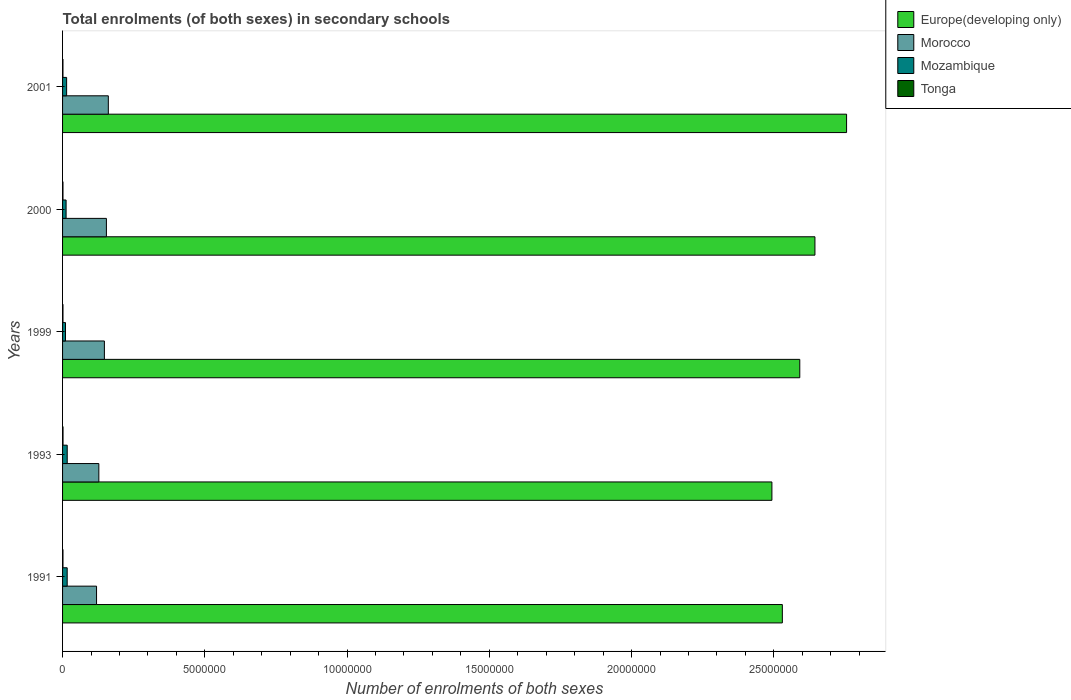How many different coloured bars are there?
Your answer should be compact. 4. How many groups of bars are there?
Make the answer very short. 5. How many bars are there on the 1st tick from the top?
Keep it short and to the point. 4. In how many cases, is the number of bars for a given year not equal to the number of legend labels?
Give a very brief answer. 0. What is the number of enrolments in secondary schools in Mozambique in 1999?
Your answer should be very brief. 1.03e+05. Across all years, what is the maximum number of enrolments in secondary schools in Mozambique?
Your response must be concise. 1.64e+05. Across all years, what is the minimum number of enrolments in secondary schools in Tonga?
Ensure brevity in your answer.  1.41e+04. In which year was the number of enrolments in secondary schools in Europe(developing only) maximum?
Give a very brief answer. 2001. In which year was the number of enrolments in secondary schools in Tonga minimum?
Your response must be concise. 2001. What is the total number of enrolments in secondary schools in Europe(developing only) in the graph?
Ensure brevity in your answer.  1.30e+08. What is the difference between the number of enrolments in secondary schools in Europe(developing only) in 1991 and that in 1993?
Your response must be concise. 3.67e+05. What is the difference between the number of enrolments in secondary schools in Europe(developing only) in 2000 and the number of enrolments in secondary schools in Morocco in 1999?
Ensure brevity in your answer.  2.50e+07. What is the average number of enrolments in secondary schools in Tonga per year?
Give a very brief answer. 1.50e+04. In the year 2001, what is the difference between the number of enrolments in secondary schools in Europe(developing only) and number of enrolments in secondary schools in Morocco?
Ensure brevity in your answer.  2.59e+07. What is the ratio of the number of enrolments in secondary schools in Tonga in 2000 to that in 2001?
Give a very brief answer. 1.03. What is the difference between the highest and the second highest number of enrolments in secondary schools in Morocco?
Offer a terse response. 6.72e+04. What is the difference between the highest and the lowest number of enrolments in secondary schools in Europe(developing only)?
Give a very brief answer. 2.62e+06. What does the 1st bar from the top in 1993 represents?
Offer a terse response. Tonga. What does the 1st bar from the bottom in 2001 represents?
Your response must be concise. Europe(developing only). Is it the case that in every year, the sum of the number of enrolments in secondary schools in Europe(developing only) and number of enrolments in secondary schools in Mozambique is greater than the number of enrolments in secondary schools in Tonga?
Provide a short and direct response. Yes. How many bars are there?
Your answer should be compact. 20. How many years are there in the graph?
Your answer should be very brief. 5. What is the difference between two consecutive major ticks on the X-axis?
Give a very brief answer. 5.00e+06. Does the graph contain grids?
Your answer should be compact. No. Where does the legend appear in the graph?
Give a very brief answer. Top right. How many legend labels are there?
Your response must be concise. 4. What is the title of the graph?
Give a very brief answer. Total enrolments (of both sexes) in secondary schools. Does "Samoa" appear as one of the legend labels in the graph?
Your response must be concise. No. What is the label or title of the X-axis?
Give a very brief answer. Number of enrolments of both sexes. What is the Number of enrolments of both sexes in Europe(developing only) in 1991?
Your answer should be compact. 2.53e+07. What is the Number of enrolments of both sexes of Morocco in 1991?
Offer a very short reply. 1.19e+06. What is the Number of enrolments of both sexes in Mozambique in 1991?
Keep it short and to the point. 1.62e+05. What is the Number of enrolments of both sexes of Tonga in 1991?
Provide a succinct answer. 1.48e+04. What is the Number of enrolments of both sexes of Europe(developing only) in 1993?
Keep it short and to the point. 2.49e+07. What is the Number of enrolments of both sexes of Morocco in 1993?
Provide a succinct answer. 1.27e+06. What is the Number of enrolments of both sexes of Mozambique in 1993?
Keep it short and to the point. 1.64e+05. What is the Number of enrolments of both sexes in Tonga in 1993?
Keep it short and to the point. 1.66e+04. What is the Number of enrolments of both sexes of Europe(developing only) in 1999?
Give a very brief answer. 2.59e+07. What is the Number of enrolments of both sexes in Morocco in 1999?
Keep it short and to the point. 1.47e+06. What is the Number of enrolments of both sexes in Mozambique in 1999?
Make the answer very short. 1.03e+05. What is the Number of enrolments of both sexes of Tonga in 1999?
Ensure brevity in your answer.  1.47e+04. What is the Number of enrolments of both sexes of Europe(developing only) in 2000?
Make the answer very short. 2.64e+07. What is the Number of enrolments of both sexes of Morocco in 2000?
Offer a terse response. 1.54e+06. What is the Number of enrolments of both sexes of Mozambique in 2000?
Provide a succinct answer. 1.24e+05. What is the Number of enrolments of both sexes in Tonga in 2000?
Give a very brief answer. 1.45e+04. What is the Number of enrolments of both sexes of Europe(developing only) in 2001?
Your response must be concise. 2.76e+07. What is the Number of enrolments of both sexes in Morocco in 2001?
Offer a terse response. 1.61e+06. What is the Number of enrolments of both sexes of Mozambique in 2001?
Ensure brevity in your answer.  1.43e+05. What is the Number of enrolments of both sexes in Tonga in 2001?
Your answer should be very brief. 1.41e+04. Across all years, what is the maximum Number of enrolments of both sexes in Europe(developing only)?
Make the answer very short. 2.76e+07. Across all years, what is the maximum Number of enrolments of both sexes of Morocco?
Your answer should be very brief. 1.61e+06. Across all years, what is the maximum Number of enrolments of both sexes in Mozambique?
Give a very brief answer. 1.64e+05. Across all years, what is the maximum Number of enrolments of both sexes of Tonga?
Your response must be concise. 1.66e+04. Across all years, what is the minimum Number of enrolments of both sexes in Europe(developing only)?
Your response must be concise. 2.49e+07. Across all years, what is the minimum Number of enrolments of both sexes in Morocco?
Provide a short and direct response. 1.19e+06. Across all years, what is the minimum Number of enrolments of both sexes in Mozambique?
Ensure brevity in your answer.  1.03e+05. Across all years, what is the minimum Number of enrolments of both sexes in Tonga?
Keep it short and to the point. 1.41e+04. What is the total Number of enrolments of both sexes of Europe(developing only) in the graph?
Offer a terse response. 1.30e+08. What is the total Number of enrolments of both sexes of Morocco in the graph?
Make the answer very short. 7.09e+06. What is the total Number of enrolments of both sexes of Mozambique in the graph?
Your answer should be very brief. 6.96e+05. What is the total Number of enrolments of both sexes in Tonga in the graph?
Ensure brevity in your answer.  7.48e+04. What is the difference between the Number of enrolments of both sexes of Europe(developing only) in 1991 and that in 1993?
Offer a terse response. 3.67e+05. What is the difference between the Number of enrolments of both sexes in Morocco in 1991 and that in 1993?
Provide a short and direct response. -8.06e+04. What is the difference between the Number of enrolments of both sexes in Mozambique in 1991 and that in 1993?
Your answer should be very brief. -1261. What is the difference between the Number of enrolments of both sexes of Tonga in 1991 and that in 1993?
Keep it short and to the point. -1745. What is the difference between the Number of enrolments of both sexes in Europe(developing only) in 1991 and that in 1999?
Ensure brevity in your answer.  -6.13e+05. What is the difference between the Number of enrolments of both sexes of Morocco in 1991 and that in 1999?
Make the answer very short. -2.75e+05. What is the difference between the Number of enrolments of both sexes in Mozambique in 1991 and that in 1999?
Give a very brief answer. 5.93e+04. What is the difference between the Number of enrolments of both sexes in Tonga in 1991 and that in 1999?
Keep it short and to the point. 115. What is the difference between the Number of enrolments of both sexes of Europe(developing only) in 1991 and that in 2000?
Give a very brief answer. -1.15e+06. What is the difference between the Number of enrolments of both sexes in Morocco in 1991 and that in 2000?
Your answer should be very brief. -3.47e+05. What is the difference between the Number of enrolments of both sexes in Mozambique in 1991 and that in 2000?
Give a very brief answer. 3.87e+04. What is the difference between the Number of enrolments of both sexes of Tonga in 1991 and that in 2000?
Your response must be concise. 301. What is the difference between the Number of enrolments of both sexes in Europe(developing only) in 1991 and that in 2001?
Provide a short and direct response. -2.26e+06. What is the difference between the Number of enrolments of both sexes of Morocco in 1991 and that in 2001?
Ensure brevity in your answer.  -4.14e+05. What is the difference between the Number of enrolments of both sexes in Mozambique in 1991 and that in 2001?
Your answer should be very brief. 1.99e+04. What is the difference between the Number of enrolments of both sexes of Tonga in 1991 and that in 2001?
Your answer should be very brief. 698. What is the difference between the Number of enrolments of both sexes in Europe(developing only) in 1993 and that in 1999?
Ensure brevity in your answer.  -9.80e+05. What is the difference between the Number of enrolments of both sexes of Morocco in 1993 and that in 1999?
Ensure brevity in your answer.  -1.95e+05. What is the difference between the Number of enrolments of both sexes in Mozambique in 1993 and that in 1999?
Provide a succinct answer. 6.06e+04. What is the difference between the Number of enrolments of both sexes of Tonga in 1993 and that in 1999?
Your response must be concise. 1860. What is the difference between the Number of enrolments of both sexes in Europe(developing only) in 1993 and that in 2000?
Ensure brevity in your answer.  -1.51e+06. What is the difference between the Number of enrolments of both sexes of Morocco in 1993 and that in 2000?
Your response must be concise. -2.66e+05. What is the difference between the Number of enrolments of both sexes in Mozambique in 1993 and that in 2000?
Provide a short and direct response. 3.99e+04. What is the difference between the Number of enrolments of both sexes of Tonga in 1993 and that in 2000?
Your answer should be compact. 2046. What is the difference between the Number of enrolments of both sexes of Europe(developing only) in 1993 and that in 2001?
Provide a succinct answer. -2.62e+06. What is the difference between the Number of enrolments of both sexes of Morocco in 1993 and that in 2001?
Keep it short and to the point. -3.33e+05. What is the difference between the Number of enrolments of both sexes of Mozambique in 1993 and that in 2001?
Provide a short and direct response. 2.12e+04. What is the difference between the Number of enrolments of both sexes in Tonga in 1993 and that in 2001?
Keep it short and to the point. 2443. What is the difference between the Number of enrolments of both sexes of Europe(developing only) in 1999 and that in 2000?
Your response must be concise. -5.33e+05. What is the difference between the Number of enrolments of both sexes of Morocco in 1999 and that in 2000?
Give a very brief answer. -7.13e+04. What is the difference between the Number of enrolments of both sexes of Mozambique in 1999 and that in 2000?
Your answer should be very brief. -2.07e+04. What is the difference between the Number of enrolments of both sexes in Tonga in 1999 and that in 2000?
Make the answer very short. 186. What is the difference between the Number of enrolments of both sexes in Europe(developing only) in 1999 and that in 2001?
Provide a succinct answer. -1.64e+06. What is the difference between the Number of enrolments of both sexes of Morocco in 1999 and that in 2001?
Provide a succinct answer. -1.38e+05. What is the difference between the Number of enrolments of both sexes in Mozambique in 1999 and that in 2001?
Your answer should be compact. -3.94e+04. What is the difference between the Number of enrolments of both sexes in Tonga in 1999 and that in 2001?
Your answer should be compact. 583. What is the difference between the Number of enrolments of both sexes in Europe(developing only) in 2000 and that in 2001?
Make the answer very short. -1.11e+06. What is the difference between the Number of enrolments of both sexes of Morocco in 2000 and that in 2001?
Make the answer very short. -6.72e+04. What is the difference between the Number of enrolments of both sexes of Mozambique in 2000 and that in 2001?
Give a very brief answer. -1.87e+04. What is the difference between the Number of enrolments of both sexes in Tonga in 2000 and that in 2001?
Keep it short and to the point. 397. What is the difference between the Number of enrolments of both sexes in Europe(developing only) in 1991 and the Number of enrolments of both sexes in Morocco in 1993?
Your answer should be compact. 2.40e+07. What is the difference between the Number of enrolments of both sexes of Europe(developing only) in 1991 and the Number of enrolments of both sexes of Mozambique in 1993?
Give a very brief answer. 2.51e+07. What is the difference between the Number of enrolments of both sexes in Europe(developing only) in 1991 and the Number of enrolments of both sexes in Tonga in 1993?
Provide a succinct answer. 2.53e+07. What is the difference between the Number of enrolments of both sexes of Morocco in 1991 and the Number of enrolments of both sexes of Mozambique in 1993?
Your response must be concise. 1.03e+06. What is the difference between the Number of enrolments of both sexes of Morocco in 1991 and the Number of enrolments of both sexes of Tonga in 1993?
Offer a terse response. 1.18e+06. What is the difference between the Number of enrolments of both sexes of Mozambique in 1991 and the Number of enrolments of both sexes of Tonga in 1993?
Your answer should be very brief. 1.46e+05. What is the difference between the Number of enrolments of both sexes in Europe(developing only) in 1991 and the Number of enrolments of both sexes in Morocco in 1999?
Your answer should be compact. 2.38e+07. What is the difference between the Number of enrolments of both sexes of Europe(developing only) in 1991 and the Number of enrolments of both sexes of Mozambique in 1999?
Provide a short and direct response. 2.52e+07. What is the difference between the Number of enrolments of both sexes in Europe(developing only) in 1991 and the Number of enrolments of both sexes in Tonga in 1999?
Ensure brevity in your answer.  2.53e+07. What is the difference between the Number of enrolments of both sexes in Morocco in 1991 and the Number of enrolments of both sexes in Mozambique in 1999?
Offer a very short reply. 1.09e+06. What is the difference between the Number of enrolments of both sexes in Morocco in 1991 and the Number of enrolments of both sexes in Tonga in 1999?
Your answer should be compact. 1.18e+06. What is the difference between the Number of enrolments of both sexes of Mozambique in 1991 and the Number of enrolments of both sexes of Tonga in 1999?
Your answer should be compact. 1.48e+05. What is the difference between the Number of enrolments of both sexes in Europe(developing only) in 1991 and the Number of enrolments of both sexes in Morocco in 2000?
Offer a very short reply. 2.38e+07. What is the difference between the Number of enrolments of both sexes in Europe(developing only) in 1991 and the Number of enrolments of both sexes in Mozambique in 2000?
Provide a succinct answer. 2.52e+07. What is the difference between the Number of enrolments of both sexes of Europe(developing only) in 1991 and the Number of enrolments of both sexes of Tonga in 2000?
Keep it short and to the point. 2.53e+07. What is the difference between the Number of enrolments of both sexes in Morocco in 1991 and the Number of enrolments of both sexes in Mozambique in 2000?
Make the answer very short. 1.07e+06. What is the difference between the Number of enrolments of both sexes in Morocco in 1991 and the Number of enrolments of both sexes in Tonga in 2000?
Your response must be concise. 1.18e+06. What is the difference between the Number of enrolments of both sexes of Mozambique in 1991 and the Number of enrolments of both sexes of Tonga in 2000?
Offer a terse response. 1.48e+05. What is the difference between the Number of enrolments of both sexes of Europe(developing only) in 1991 and the Number of enrolments of both sexes of Morocco in 2001?
Make the answer very short. 2.37e+07. What is the difference between the Number of enrolments of both sexes of Europe(developing only) in 1991 and the Number of enrolments of both sexes of Mozambique in 2001?
Make the answer very short. 2.52e+07. What is the difference between the Number of enrolments of both sexes in Europe(developing only) in 1991 and the Number of enrolments of both sexes in Tonga in 2001?
Ensure brevity in your answer.  2.53e+07. What is the difference between the Number of enrolments of both sexes of Morocco in 1991 and the Number of enrolments of both sexes of Mozambique in 2001?
Provide a succinct answer. 1.05e+06. What is the difference between the Number of enrolments of both sexes of Morocco in 1991 and the Number of enrolments of both sexes of Tonga in 2001?
Provide a succinct answer. 1.18e+06. What is the difference between the Number of enrolments of both sexes in Mozambique in 1991 and the Number of enrolments of both sexes in Tonga in 2001?
Offer a terse response. 1.48e+05. What is the difference between the Number of enrolments of both sexes in Europe(developing only) in 1993 and the Number of enrolments of both sexes in Morocco in 1999?
Provide a succinct answer. 2.35e+07. What is the difference between the Number of enrolments of both sexes of Europe(developing only) in 1993 and the Number of enrolments of both sexes of Mozambique in 1999?
Your response must be concise. 2.48e+07. What is the difference between the Number of enrolments of both sexes in Europe(developing only) in 1993 and the Number of enrolments of both sexes in Tonga in 1999?
Your answer should be very brief. 2.49e+07. What is the difference between the Number of enrolments of both sexes in Morocco in 1993 and the Number of enrolments of both sexes in Mozambique in 1999?
Offer a terse response. 1.17e+06. What is the difference between the Number of enrolments of both sexes of Morocco in 1993 and the Number of enrolments of both sexes of Tonga in 1999?
Your answer should be very brief. 1.26e+06. What is the difference between the Number of enrolments of both sexes of Mozambique in 1993 and the Number of enrolments of both sexes of Tonga in 1999?
Provide a succinct answer. 1.49e+05. What is the difference between the Number of enrolments of both sexes of Europe(developing only) in 1993 and the Number of enrolments of both sexes of Morocco in 2000?
Provide a short and direct response. 2.34e+07. What is the difference between the Number of enrolments of both sexes of Europe(developing only) in 1993 and the Number of enrolments of both sexes of Mozambique in 2000?
Make the answer very short. 2.48e+07. What is the difference between the Number of enrolments of both sexes of Europe(developing only) in 1993 and the Number of enrolments of both sexes of Tonga in 2000?
Offer a very short reply. 2.49e+07. What is the difference between the Number of enrolments of both sexes in Morocco in 1993 and the Number of enrolments of both sexes in Mozambique in 2000?
Provide a succinct answer. 1.15e+06. What is the difference between the Number of enrolments of both sexes of Morocco in 1993 and the Number of enrolments of both sexes of Tonga in 2000?
Offer a very short reply. 1.26e+06. What is the difference between the Number of enrolments of both sexes in Mozambique in 1993 and the Number of enrolments of both sexes in Tonga in 2000?
Offer a terse response. 1.49e+05. What is the difference between the Number of enrolments of both sexes in Europe(developing only) in 1993 and the Number of enrolments of both sexes in Morocco in 2001?
Ensure brevity in your answer.  2.33e+07. What is the difference between the Number of enrolments of both sexes in Europe(developing only) in 1993 and the Number of enrolments of both sexes in Mozambique in 2001?
Make the answer very short. 2.48e+07. What is the difference between the Number of enrolments of both sexes of Europe(developing only) in 1993 and the Number of enrolments of both sexes of Tonga in 2001?
Give a very brief answer. 2.49e+07. What is the difference between the Number of enrolments of both sexes in Morocco in 1993 and the Number of enrolments of both sexes in Mozambique in 2001?
Give a very brief answer. 1.13e+06. What is the difference between the Number of enrolments of both sexes in Morocco in 1993 and the Number of enrolments of both sexes in Tonga in 2001?
Your answer should be very brief. 1.26e+06. What is the difference between the Number of enrolments of both sexes of Mozambique in 1993 and the Number of enrolments of both sexes of Tonga in 2001?
Offer a terse response. 1.50e+05. What is the difference between the Number of enrolments of both sexes in Europe(developing only) in 1999 and the Number of enrolments of both sexes in Morocco in 2000?
Offer a very short reply. 2.44e+07. What is the difference between the Number of enrolments of both sexes of Europe(developing only) in 1999 and the Number of enrolments of both sexes of Mozambique in 2000?
Provide a short and direct response. 2.58e+07. What is the difference between the Number of enrolments of both sexes of Europe(developing only) in 1999 and the Number of enrolments of both sexes of Tonga in 2000?
Keep it short and to the point. 2.59e+07. What is the difference between the Number of enrolments of both sexes in Morocco in 1999 and the Number of enrolments of both sexes in Mozambique in 2000?
Keep it short and to the point. 1.35e+06. What is the difference between the Number of enrolments of both sexes in Morocco in 1999 and the Number of enrolments of both sexes in Tonga in 2000?
Provide a short and direct response. 1.46e+06. What is the difference between the Number of enrolments of both sexes in Mozambique in 1999 and the Number of enrolments of both sexes in Tonga in 2000?
Your response must be concise. 8.86e+04. What is the difference between the Number of enrolments of both sexes of Europe(developing only) in 1999 and the Number of enrolments of both sexes of Morocco in 2001?
Offer a very short reply. 2.43e+07. What is the difference between the Number of enrolments of both sexes of Europe(developing only) in 1999 and the Number of enrolments of both sexes of Mozambique in 2001?
Give a very brief answer. 2.58e+07. What is the difference between the Number of enrolments of both sexes in Europe(developing only) in 1999 and the Number of enrolments of both sexes in Tonga in 2001?
Ensure brevity in your answer.  2.59e+07. What is the difference between the Number of enrolments of both sexes of Morocco in 1999 and the Number of enrolments of both sexes of Mozambique in 2001?
Your response must be concise. 1.33e+06. What is the difference between the Number of enrolments of both sexes of Morocco in 1999 and the Number of enrolments of both sexes of Tonga in 2001?
Offer a very short reply. 1.46e+06. What is the difference between the Number of enrolments of both sexes in Mozambique in 1999 and the Number of enrolments of both sexes in Tonga in 2001?
Your response must be concise. 8.90e+04. What is the difference between the Number of enrolments of both sexes of Europe(developing only) in 2000 and the Number of enrolments of both sexes of Morocco in 2001?
Your response must be concise. 2.48e+07. What is the difference between the Number of enrolments of both sexes in Europe(developing only) in 2000 and the Number of enrolments of both sexes in Mozambique in 2001?
Your answer should be compact. 2.63e+07. What is the difference between the Number of enrolments of both sexes in Europe(developing only) in 2000 and the Number of enrolments of both sexes in Tonga in 2001?
Your response must be concise. 2.64e+07. What is the difference between the Number of enrolments of both sexes in Morocco in 2000 and the Number of enrolments of both sexes in Mozambique in 2001?
Your answer should be very brief. 1.40e+06. What is the difference between the Number of enrolments of both sexes of Morocco in 2000 and the Number of enrolments of both sexes of Tonga in 2001?
Your response must be concise. 1.53e+06. What is the difference between the Number of enrolments of both sexes in Mozambique in 2000 and the Number of enrolments of both sexes in Tonga in 2001?
Offer a very short reply. 1.10e+05. What is the average Number of enrolments of both sexes in Europe(developing only) per year?
Ensure brevity in your answer.  2.60e+07. What is the average Number of enrolments of both sexes in Morocco per year?
Your answer should be very brief. 1.42e+06. What is the average Number of enrolments of both sexes of Mozambique per year?
Your response must be concise. 1.39e+05. What is the average Number of enrolments of both sexes of Tonga per year?
Ensure brevity in your answer.  1.50e+04. In the year 1991, what is the difference between the Number of enrolments of both sexes of Europe(developing only) and Number of enrolments of both sexes of Morocco?
Provide a short and direct response. 2.41e+07. In the year 1991, what is the difference between the Number of enrolments of both sexes in Europe(developing only) and Number of enrolments of both sexes in Mozambique?
Offer a terse response. 2.51e+07. In the year 1991, what is the difference between the Number of enrolments of both sexes in Europe(developing only) and Number of enrolments of both sexes in Tonga?
Make the answer very short. 2.53e+07. In the year 1991, what is the difference between the Number of enrolments of both sexes of Morocco and Number of enrolments of both sexes of Mozambique?
Your answer should be compact. 1.03e+06. In the year 1991, what is the difference between the Number of enrolments of both sexes in Morocco and Number of enrolments of both sexes in Tonga?
Your response must be concise. 1.18e+06. In the year 1991, what is the difference between the Number of enrolments of both sexes in Mozambique and Number of enrolments of both sexes in Tonga?
Give a very brief answer. 1.48e+05. In the year 1993, what is the difference between the Number of enrolments of both sexes in Europe(developing only) and Number of enrolments of both sexes in Morocco?
Keep it short and to the point. 2.37e+07. In the year 1993, what is the difference between the Number of enrolments of both sexes in Europe(developing only) and Number of enrolments of both sexes in Mozambique?
Make the answer very short. 2.48e+07. In the year 1993, what is the difference between the Number of enrolments of both sexes in Europe(developing only) and Number of enrolments of both sexes in Tonga?
Ensure brevity in your answer.  2.49e+07. In the year 1993, what is the difference between the Number of enrolments of both sexes in Morocco and Number of enrolments of both sexes in Mozambique?
Give a very brief answer. 1.11e+06. In the year 1993, what is the difference between the Number of enrolments of both sexes in Morocco and Number of enrolments of both sexes in Tonga?
Provide a succinct answer. 1.26e+06. In the year 1993, what is the difference between the Number of enrolments of both sexes of Mozambique and Number of enrolments of both sexes of Tonga?
Your answer should be compact. 1.47e+05. In the year 1999, what is the difference between the Number of enrolments of both sexes of Europe(developing only) and Number of enrolments of both sexes of Morocco?
Give a very brief answer. 2.44e+07. In the year 1999, what is the difference between the Number of enrolments of both sexes of Europe(developing only) and Number of enrolments of both sexes of Mozambique?
Give a very brief answer. 2.58e+07. In the year 1999, what is the difference between the Number of enrolments of both sexes in Europe(developing only) and Number of enrolments of both sexes in Tonga?
Keep it short and to the point. 2.59e+07. In the year 1999, what is the difference between the Number of enrolments of both sexes of Morocco and Number of enrolments of both sexes of Mozambique?
Provide a succinct answer. 1.37e+06. In the year 1999, what is the difference between the Number of enrolments of both sexes in Morocco and Number of enrolments of both sexes in Tonga?
Offer a very short reply. 1.46e+06. In the year 1999, what is the difference between the Number of enrolments of both sexes of Mozambique and Number of enrolments of both sexes of Tonga?
Your answer should be compact. 8.84e+04. In the year 2000, what is the difference between the Number of enrolments of both sexes in Europe(developing only) and Number of enrolments of both sexes in Morocco?
Ensure brevity in your answer.  2.49e+07. In the year 2000, what is the difference between the Number of enrolments of both sexes in Europe(developing only) and Number of enrolments of both sexes in Mozambique?
Keep it short and to the point. 2.63e+07. In the year 2000, what is the difference between the Number of enrolments of both sexes of Europe(developing only) and Number of enrolments of both sexes of Tonga?
Offer a terse response. 2.64e+07. In the year 2000, what is the difference between the Number of enrolments of both sexes in Morocco and Number of enrolments of both sexes in Mozambique?
Your response must be concise. 1.42e+06. In the year 2000, what is the difference between the Number of enrolments of both sexes of Morocco and Number of enrolments of both sexes of Tonga?
Give a very brief answer. 1.53e+06. In the year 2000, what is the difference between the Number of enrolments of both sexes of Mozambique and Number of enrolments of both sexes of Tonga?
Give a very brief answer. 1.09e+05. In the year 2001, what is the difference between the Number of enrolments of both sexes in Europe(developing only) and Number of enrolments of both sexes in Morocco?
Keep it short and to the point. 2.59e+07. In the year 2001, what is the difference between the Number of enrolments of both sexes in Europe(developing only) and Number of enrolments of both sexes in Mozambique?
Your response must be concise. 2.74e+07. In the year 2001, what is the difference between the Number of enrolments of both sexes of Europe(developing only) and Number of enrolments of both sexes of Tonga?
Your response must be concise. 2.75e+07. In the year 2001, what is the difference between the Number of enrolments of both sexes in Morocco and Number of enrolments of both sexes in Mozambique?
Your answer should be very brief. 1.47e+06. In the year 2001, what is the difference between the Number of enrolments of both sexes in Morocco and Number of enrolments of both sexes in Tonga?
Offer a very short reply. 1.59e+06. In the year 2001, what is the difference between the Number of enrolments of both sexes of Mozambique and Number of enrolments of both sexes of Tonga?
Provide a short and direct response. 1.28e+05. What is the ratio of the Number of enrolments of both sexes of Europe(developing only) in 1991 to that in 1993?
Provide a succinct answer. 1.01. What is the ratio of the Number of enrolments of both sexes in Morocco in 1991 to that in 1993?
Offer a terse response. 0.94. What is the ratio of the Number of enrolments of both sexes in Tonga in 1991 to that in 1993?
Your response must be concise. 0.89. What is the ratio of the Number of enrolments of both sexes in Europe(developing only) in 1991 to that in 1999?
Offer a terse response. 0.98. What is the ratio of the Number of enrolments of both sexes in Morocco in 1991 to that in 1999?
Make the answer very short. 0.81. What is the ratio of the Number of enrolments of both sexes in Mozambique in 1991 to that in 1999?
Provide a short and direct response. 1.58. What is the ratio of the Number of enrolments of both sexes of Tonga in 1991 to that in 1999?
Offer a very short reply. 1.01. What is the ratio of the Number of enrolments of both sexes of Europe(developing only) in 1991 to that in 2000?
Ensure brevity in your answer.  0.96. What is the ratio of the Number of enrolments of both sexes of Morocco in 1991 to that in 2000?
Your answer should be very brief. 0.78. What is the ratio of the Number of enrolments of both sexes of Mozambique in 1991 to that in 2000?
Your answer should be compact. 1.31. What is the ratio of the Number of enrolments of both sexes of Tonga in 1991 to that in 2000?
Provide a short and direct response. 1.02. What is the ratio of the Number of enrolments of both sexes in Europe(developing only) in 1991 to that in 2001?
Make the answer very short. 0.92. What is the ratio of the Number of enrolments of both sexes of Morocco in 1991 to that in 2001?
Provide a short and direct response. 0.74. What is the ratio of the Number of enrolments of both sexes in Mozambique in 1991 to that in 2001?
Give a very brief answer. 1.14. What is the ratio of the Number of enrolments of both sexes in Tonga in 1991 to that in 2001?
Your response must be concise. 1.05. What is the ratio of the Number of enrolments of both sexes of Europe(developing only) in 1993 to that in 1999?
Keep it short and to the point. 0.96. What is the ratio of the Number of enrolments of both sexes in Morocco in 1993 to that in 1999?
Your response must be concise. 0.87. What is the ratio of the Number of enrolments of both sexes in Mozambique in 1993 to that in 1999?
Ensure brevity in your answer.  1.59. What is the ratio of the Number of enrolments of both sexes in Tonga in 1993 to that in 1999?
Offer a terse response. 1.13. What is the ratio of the Number of enrolments of both sexes in Europe(developing only) in 1993 to that in 2000?
Offer a very short reply. 0.94. What is the ratio of the Number of enrolments of both sexes in Morocco in 1993 to that in 2000?
Make the answer very short. 0.83. What is the ratio of the Number of enrolments of both sexes of Mozambique in 1993 to that in 2000?
Your response must be concise. 1.32. What is the ratio of the Number of enrolments of both sexes of Tonga in 1993 to that in 2000?
Ensure brevity in your answer.  1.14. What is the ratio of the Number of enrolments of both sexes in Europe(developing only) in 1993 to that in 2001?
Your response must be concise. 0.9. What is the ratio of the Number of enrolments of both sexes in Morocco in 1993 to that in 2001?
Give a very brief answer. 0.79. What is the ratio of the Number of enrolments of both sexes in Mozambique in 1993 to that in 2001?
Give a very brief answer. 1.15. What is the ratio of the Number of enrolments of both sexes in Tonga in 1993 to that in 2001?
Your answer should be compact. 1.17. What is the ratio of the Number of enrolments of both sexes of Europe(developing only) in 1999 to that in 2000?
Provide a succinct answer. 0.98. What is the ratio of the Number of enrolments of both sexes of Morocco in 1999 to that in 2000?
Give a very brief answer. 0.95. What is the ratio of the Number of enrolments of both sexes in Mozambique in 1999 to that in 2000?
Offer a very short reply. 0.83. What is the ratio of the Number of enrolments of both sexes in Tonga in 1999 to that in 2000?
Keep it short and to the point. 1.01. What is the ratio of the Number of enrolments of both sexes of Europe(developing only) in 1999 to that in 2001?
Make the answer very short. 0.94. What is the ratio of the Number of enrolments of both sexes in Morocco in 1999 to that in 2001?
Make the answer very short. 0.91. What is the ratio of the Number of enrolments of both sexes in Mozambique in 1999 to that in 2001?
Your answer should be very brief. 0.72. What is the ratio of the Number of enrolments of both sexes in Tonga in 1999 to that in 2001?
Offer a terse response. 1.04. What is the ratio of the Number of enrolments of both sexes of Europe(developing only) in 2000 to that in 2001?
Your answer should be compact. 0.96. What is the ratio of the Number of enrolments of both sexes of Morocco in 2000 to that in 2001?
Provide a short and direct response. 0.96. What is the ratio of the Number of enrolments of both sexes of Mozambique in 2000 to that in 2001?
Your answer should be compact. 0.87. What is the ratio of the Number of enrolments of both sexes of Tonga in 2000 to that in 2001?
Offer a terse response. 1.03. What is the difference between the highest and the second highest Number of enrolments of both sexes in Europe(developing only)?
Ensure brevity in your answer.  1.11e+06. What is the difference between the highest and the second highest Number of enrolments of both sexes of Morocco?
Your answer should be very brief. 6.72e+04. What is the difference between the highest and the second highest Number of enrolments of both sexes in Mozambique?
Provide a succinct answer. 1261. What is the difference between the highest and the second highest Number of enrolments of both sexes in Tonga?
Your answer should be compact. 1745. What is the difference between the highest and the lowest Number of enrolments of both sexes of Europe(developing only)?
Ensure brevity in your answer.  2.62e+06. What is the difference between the highest and the lowest Number of enrolments of both sexes of Morocco?
Your answer should be compact. 4.14e+05. What is the difference between the highest and the lowest Number of enrolments of both sexes in Mozambique?
Offer a very short reply. 6.06e+04. What is the difference between the highest and the lowest Number of enrolments of both sexes in Tonga?
Your response must be concise. 2443. 